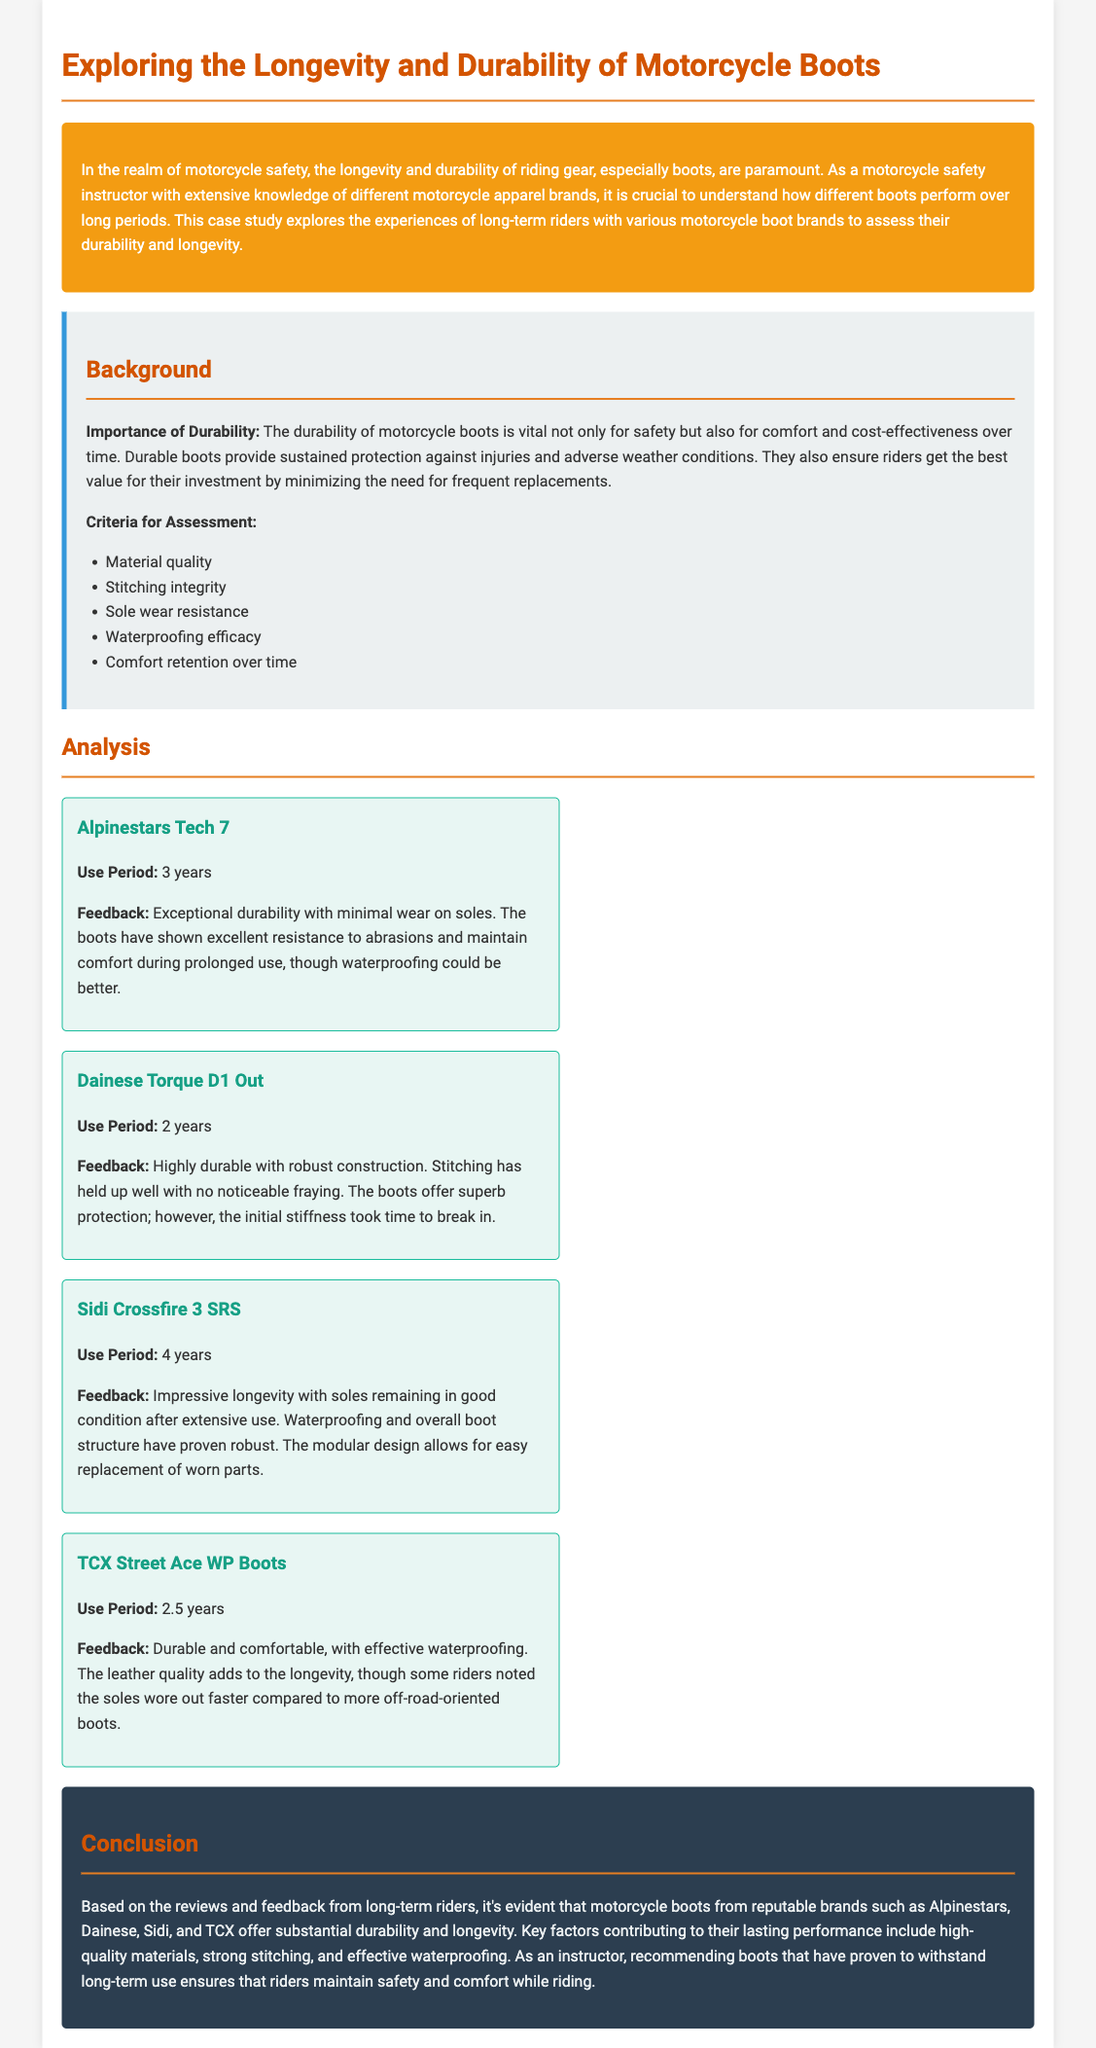What is the use period for Alpinestars Tech 7? The use period for Alpinestars Tech 7 is specified in the document as 3 years.
Answer: 3 years What does the feedback for Dainese Torque D1 Out highlight? The feedback for Dainese Torque D1 Out highlights its highly durable and robust construction with no noticeable fraying in the stitching.
Answer: Robust construction How long did the Sidi Crossfire 3 SRS last? The document states that the Sidi Crossfire 3 SRS has a use period of 4 years.
Answer: 4 years What is a key factor contributing to the longevity of motorcycle boots? The document lists high-quality materials as one of the key factors contributing to the longevity of motorcycle boots.
Answer: High-quality materials Which boot has effective waterproofing according to the document? According to the document, the TCX Street Ace WP Boots have effective waterproofing.
Answer: TCX Street Ace WP Boots What is the recommended boot brand based on long-term use? The document mentions Alpinestars, Dainese, Sidi, and TCX as recommended boot brands based on long-term use.
Answer: Alpinestars, Dainese, Sidi, TCX What conclusion is drawn about the motorcycle boot reviews? The conclusion drawn about the motorcycle boot reviews is that they offer substantial durability and longevity.
Answer: Substantial durability and longevity What does the waterproofing efficacy criterion assess? The waterproofing efficacy criterion assesses the effectiveness of the boot in preventing water penetration.
Answer: Effectiveness in preventing water penetration 